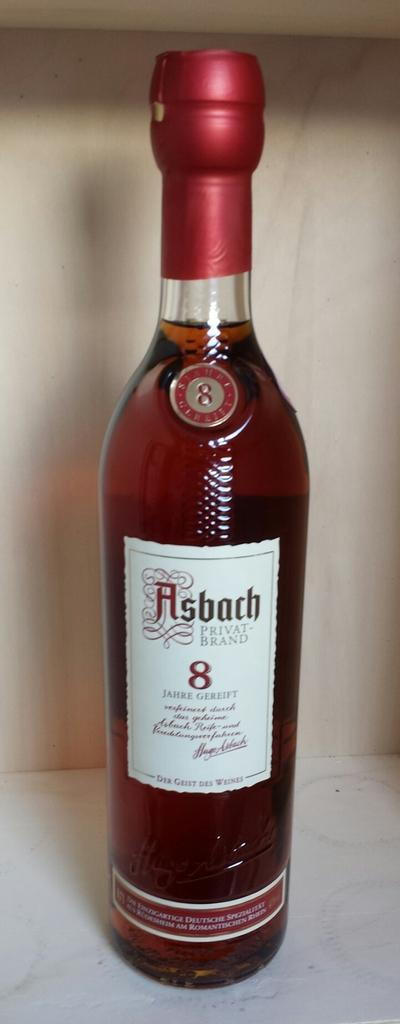<image>
Offer a succinct explanation of the picture presented. Bottle of Asbach with a red cap and a number 8 on the label. 